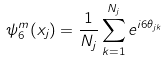Convert formula to latex. <formula><loc_0><loc_0><loc_500><loc_500>\psi ^ { m } _ { 6 } ( x _ { j } ) = \frac { 1 } { N _ { j } } \sum _ { k = 1 } ^ { N _ { j } } e ^ { i 6 \theta _ { j k } }</formula> 